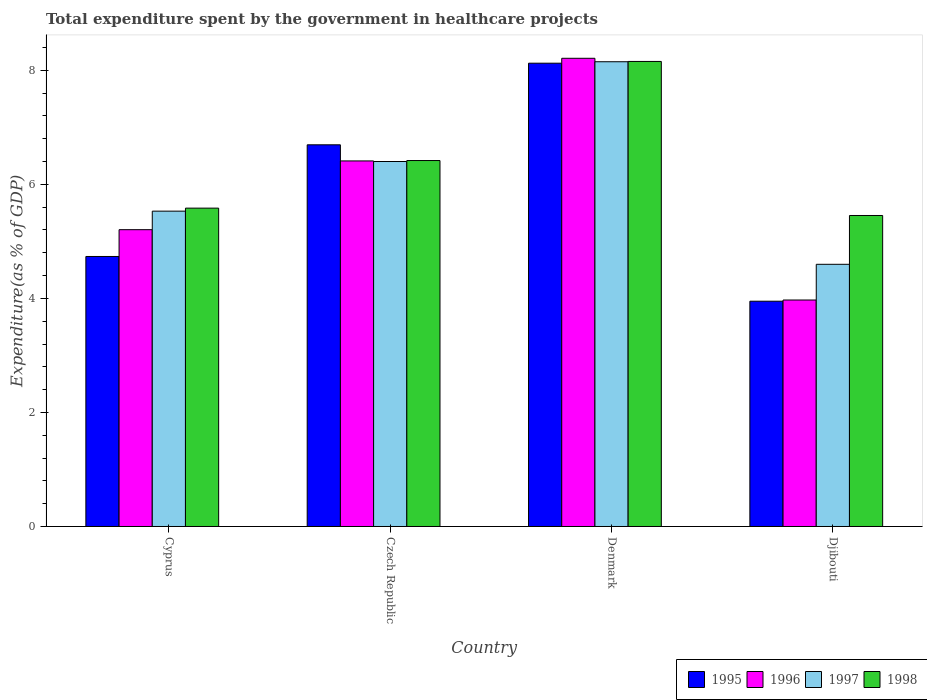How many groups of bars are there?
Make the answer very short. 4. Are the number of bars per tick equal to the number of legend labels?
Offer a very short reply. Yes. How many bars are there on the 1st tick from the right?
Make the answer very short. 4. What is the label of the 2nd group of bars from the left?
Offer a terse response. Czech Republic. In how many cases, is the number of bars for a given country not equal to the number of legend labels?
Keep it short and to the point. 0. What is the total expenditure spent by the government in healthcare projects in 1995 in Czech Republic?
Your answer should be compact. 6.69. Across all countries, what is the maximum total expenditure spent by the government in healthcare projects in 1998?
Your response must be concise. 8.16. Across all countries, what is the minimum total expenditure spent by the government in healthcare projects in 1995?
Provide a short and direct response. 3.95. In which country was the total expenditure spent by the government in healthcare projects in 1997 maximum?
Your answer should be compact. Denmark. In which country was the total expenditure spent by the government in healthcare projects in 1997 minimum?
Offer a very short reply. Djibouti. What is the total total expenditure spent by the government in healthcare projects in 1998 in the graph?
Your response must be concise. 25.61. What is the difference between the total expenditure spent by the government in healthcare projects in 1997 in Czech Republic and that in Djibouti?
Ensure brevity in your answer.  1.8. What is the difference between the total expenditure spent by the government in healthcare projects in 1995 in Denmark and the total expenditure spent by the government in healthcare projects in 1998 in Czech Republic?
Offer a very short reply. 1.71. What is the average total expenditure spent by the government in healthcare projects in 1996 per country?
Provide a short and direct response. 5.95. What is the difference between the total expenditure spent by the government in healthcare projects of/in 1997 and total expenditure spent by the government in healthcare projects of/in 1996 in Cyprus?
Your answer should be very brief. 0.32. What is the ratio of the total expenditure spent by the government in healthcare projects in 1997 in Denmark to that in Djibouti?
Offer a terse response. 1.77. Is the difference between the total expenditure spent by the government in healthcare projects in 1997 in Cyprus and Czech Republic greater than the difference between the total expenditure spent by the government in healthcare projects in 1996 in Cyprus and Czech Republic?
Ensure brevity in your answer.  Yes. What is the difference between the highest and the second highest total expenditure spent by the government in healthcare projects in 1996?
Offer a very short reply. 3.01. What is the difference between the highest and the lowest total expenditure spent by the government in healthcare projects in 1996?
Ensure brevity in your answer.  4.24. In how many countries, is the total expenditure spent by the government in healthcare projects in 1996 greater than the average total expenditure spent by the government in healthcare projects in 1996 taken over all countries?
Ensure brevity in your answer.  2. Is the sum of the total expenditure spent by the government in healthcare projects in 1997 in Denmark and Djibouti greater than the maximum total expenditure spent by the government in healthcare projects in 1996 across all countries?
Make the answer very short. Yes. Is it the case that in every country, the sum of the total expenditure spent by the government in healthcare projects in 1997 and total expenditure spent by the government in healthcare projects in 1996 is greater than the sum of total expenditure spent by the government in healthcare projects in 1995 and total expenditure spent by the government in healthcare projects in 1998?
Make the answer very short. No. What does the 4th bar from the left in Denmark represents?
Give a very brief answer. 1998. Are all the bars in the graph horizontal?
Your answer should be very brief. No. What is the difference between two consecutive major ticks on the Y-axis?
Provide a short and direct response. 2. Does the graph contain any zero values?
Your answer should be compact. No. Where does the legend appear in the graph?
Make the answer very short. Bottom right. How are the legend labels stacked?
Your answer should be compact. Horizontal. What is the title of the graph?
Offer a terse response. Total expenditure spent by the government in healthcare projects. Does "1984" appear as one of the legend labels in the graph?
Make the answer very short. No. What is the label or title of the Y-axis?
Ensure brevity in your answer.  Expenditure(as % of GDP). What is the Expenditure(as % of GDP) in 1995 in Cyprus?
Your response must be concise. 4.74. What is the Expenditure(as % of GDP) of 1996 in Cyprus?
Provide a succinct answer. 5.21. What is the Expenditure(as % of GDP) in 1997 in Cyprus?
Your answer should be very brief. 5.53. What is the Expenditure(as % of GDP) in 1998 in Cyprus?
Give a very brief answer. 5.58. What is the Expenditure(as % of GDP) in 1995 in Czech Republic?
Provide a short and direct response. 6.69. What is the Expenditure(as % of GDP) of 1996 in Czech Republic?
Offer a terse response. 6.41. What is the Expenditure(as % of GDP) of 1997 in Czech Republic?
Your answer should be very brief. 6.4. What is the Expenditure(as % of GDP) in 1998 in Czech Republic?
Ensure brevity in your answer.  6.42. What is the Expenditure(as % of GDP) of 1995 in Denmark?
Ensure brevity in your answer.  8.13. What is the Expenditure(as % of GDP) in 1996 in Denmark?
Your response must be concise. 8.21. What is the Expenditure(as % of GDP) of 1997 in Denmark?
Give a very brief answer. 8.15. What is the Expenditure(as % of GDP) in 1998 in Denmark?
Offer a terse response. 8.16. What is the Expenditure(as % of GDP) in 1995 in Djibouti?
Your answer should be compact. 3.95. What is the Expenditure(as % of GDP) of 1996 in Djibouti?
Your answer should be compact. 3.97. What is the Expenditure(as % of GDP) in 1997 in Djibouti?
Your response must be concise. 4.6. What is the Expenditure(as % of GDP) in 1998 in Djibouti?
Keep it short and to the point. 5.45. Across all countries, what is the maximum Expenditure(as % of GDP) of 1995?
Your answer should be very brief. 8.13. Across all countries, what is the maximum Expenditure(as % of GDP) of 1996?
Offer a very short reply. 8.21. Across all countries, what is the maximum Expenditure(as % of GDP) in 1997?
Your answer should be compact. 8.15. Across all countries, what is the maximum Expenditure(as % of GDP) in 1998?
Your response must be concise. 8.16. Across all countries, what is the minimum Expenditure(as % of GDP) of 1995?
Ensure brevity in your answer.  3.95. Across all countries, what is the minimum Expenditure(as % of GDP) of 1996?
Offer a very short reply. 3.97. Across all countries, what is the minimum Expenditure(as % of GDP) in 1997?
Offer a terse response. 4.6. Across all countries, what is the minimum Expenditure(as % of GDP) of 1998?
Give a very brief answer. 5.45. What is the total Expenditure(as % of GDP) of 1995 in the graph?
Keep it short and to the point. 23.51. What is the total Expenditure(as % of GDP) in 1996 in the graph?
Provide a succinct answer. 23.8. What is the total Expenditure(as % of GDP) in 1997 in the graph?
Make the answer very short. 24.68. What is the total Expenditure(as % of GDP) in 1998 in the graph?
Keep it short and to the point. 25.61. What is the difference between the Expenditure(as % of GDP) in 1995 in Cyprus and that in Czech Republic?
Give a very brief answer. -1.96. What is the difference between the Expenditure(as % of GDP) of 1996 in Cyprus and that in Czech Republic?
Your answer should be compact. -1.21. What is the difference between the Expenditure(as % of GDP) of 1997 in Cyprus and that in Czech Republic?
Your response must be concise. -0.87. What is the difference between the Expenditure(as % of GDP) in 1998 in Cyprus and that in Czech Republic?
Offer a terse response. -0.83. What is the difference between the Expenditure(as % of GDP) of 1995 in Cyprus and that in Denmark?
Provide a short and direct response. -3.39. What is the difference between the Expenditure(as % of GDP) of 1996 in Cyprus and that in Denmark?
Offer a very short reply. -3.01. What is the difference between the Expenditure(as % of GDP) of 1997 in Cyprus and that in Denmark?
Your answer should be compact. -2.62. What is the difference between the Expenditure(as % of GDP) of 1998 in Cyprus and that in Denmark?
Your response must be concise. -2.57. What is the difference between the Expenditure(as % of GDP) in 1995 in Cyprus and that in Djibouti?
Make the answer very short. 0.78. What is the difference between the Expenditure(as % of GDP) of 1996 in Cyprus and that in Djibouti?
Ensure brevity in your answer.  1.23. What is the difference between the Expenditure(as % of GDP) in 1997 in Cyprus and that in Djibouti?
Your response must be concise. 0.93. What is the difference between the Expenditure(as % of GDP) of 1998 in Cyprus and that in Djibouti?
Ensure brevity in your answer.  0.13. What is the difference between the Expenditure(as % of GDP) in 1995 in Czech Republic and that in Denmark?
Ensure brevity in your answer.  -1.43. What is the difference between the Expenditure(as % of GDP) of 1996 in Czech Republic and that in Denmark?
Your answer should be very brief. -1.8. What is the difference between the Expenditure(as % of GDP) in 1997 in Czech Republic and that in Denmark?
Provide a short and direct response. -1.75. What is the difference between the Expenditure(as % of GDP) of 1998 in Czech Republic and that in Denmark?
Provide a succinct answer. -1.74. What is the difference between the Expenditure(as % of GDP) of 1995 in Czech Republic and that in Djibouti?
Provide a succinct answer. 2.74. What is the difference between the Expenditure(as % of GDP) of 1996 in Czech Republic and that in Djibouti?
Offer a very short reply. 2.44. What is the difference between the Expenditure(as % of GDP) of 1997 in Czech Republic and that in Djibouti?
Keep it short and to the point. 1.8. What is the difference between the Expenditure(as % of GDP) of 1998 in Czech Republic and that in Djibouti?
Your answer should be very brief. 0.96. What is the difference between the Expenditure(as % of GDP) in 1995 in Denmark and that in Djibouti?
Your response must be concise. 4.17. What is the difference between the Expenditure(as % of GDP) in 1996 in Denmark and that in Djibouti?
Provide a short and direct response. 4.24. What is the difference between the Expenditure(as % of GDP) of 1997 in Denmark and that in Djibouti?
Your answer should be very brief. 3.55. What is the difference between the Expenditure(as % of GDP) of 1998 in Denmark and that in Djibouti?
Your answer should be very brief. 2.7. What is the difference between the Expenditure(as % of GDP) in 1995 in Cyprus and the Expenditure(as % of GDP) in 1996 in Czech Republic?
Keep it short and to the point. -1.68. What is the difference between the Expenditure(as % of GDP) of 1995 in Cyprus and the Expenditure(as % of GDP) of 1997 in Czech Republic?
Your answer should be very brief. -1.67. What is the difference between the Expenditure(as % of GDP) in 1995 in Cyprus and the Expenditure(as % of GDP) in 1998 in Czech Republic?
Offer a very short reply. -1.68. What is the difference between the Expenditure(as % of GDP) in 1996 in Cyprus and the Expenditure(as % of GDP) in 1997 in Czech Republic?
Your answer should be compact. -1.2. What is the difference between the Expenditure(as % of GDP) in 1996 in Cyprus and the Expenditure(as % of GDP) in 1998 in Czech Republic?
Offer a very short reply. -1.21. What is the difference between the Expenditure(as % of GDP) of 1997 in Cyprus and the Expenditure(as % of GDP) of 1998 in Czech Republic?
Your response must be concise. -0.89. What is the difference between the Expenditure(as % of GDP) in 1995 in Cyprus and the Expenditure(as % of GDP) in 1996 in Denmark?
Your answer should be very brief. -3.48. What is the difference between the Expenditure(as % of GDP) of 1995 in Cyprus and the Expenditure(as % of GDP) of 1997 in Denmark?
Provide a succinct answer. -3.42. What is the difference between the Expenditure(as % of GDP) in 1995 in Cyprus and the Expenditure(as % of GDP) in 1998 in Denmark?
Your response must be concise. -3.42. What is the difference between the Expenditure(as % of GDP) of 1996 in Cyprus and the Expenditure(as % of GDP) of 1997 in Denmark?
Provide a short and direct response. -2.95. What is the difference between the Expenditure(as % of GDP) of 1996 in Cyprus and the Expenditure(as % of GDP) of 1998 in Denmark?
Provide a short and direct response. -2.95. What is the difference between the Expenditure(as % of GDP) in 1997 in Cyprus and the Expenditure(as % of GDP) in 1998 in Denmark?
Your answer should be very brief. -2.63. What is the difference between the Expenditure(as % of GDP) in 1995 in Cyprus and the Expenditure(as % of GDP) in 1996 in Djibouti?
Your answer should be compact. 0.76. What is the difference between the Expenditure(as % of GDP) of 1995 in Cyprus and the Expenditure(as % of GDP) of 1997 in Djibouti?
Ensure brevity in your answer.  0.14. What is the difference between the Expenditure(as % of GDP) in 1995 in Cyprus and the Expenditure(as % of GDP) in 1998 in Djibouti?
Give a very brief answer. -0.72. What is the difference between the Expenditure(as % of GDP) in 1996 in Cyprus and the Expenditure(as % of GDP) in 1997 in Djibouti?
Give a very brief answer. 0.61. What is the difference between the Expenditure(as % of GDP) of 1996 in Cyprus and the Expenditure(as % of GDP) of 1998 in Djibouti?
Provide a short and direct response. -0.25. What is the difference between the Expenditure(as % of GDP) in 1997 in Cyprus and the Expenditure(as % of GDP) in 1998 in Djibouti?
Ensure brevity in your answer.  0.08. What is the difference between the Expenditure(as % of GDP) of 1995 in Czech Republic and the Expenditure(as % of GDP) of 1996 in Denmark?
Your answer should be very brief. -1.52. What is the difference between the Expenditure(as % of GDP) of 1995 in Czech Republic and the Expenditure(as % of GDP) of 1997 in Denmark?
Your answer should be very brief. -1.46. What is the difference between the Expenditure(as % of GDP) of 1995 in Czech Republic and the Expenditure(as % of GDP) of 1998 in Denmark?
Provide a succinct answer. -1.46. What is the difference between the Expenditure(as % of GDP) of 1996 in Czech Republic and the Expenditure(as % of GDP) of 1997 in Denmark?
Ensure brevity in your answer.  -1.74. What is the difference between the Expenditure(as % of GDP) of 1996 in Czech Republic and the Expenditure(as % of GDP) of 1998 in Denmark?
Keep it short and to the point. -1.74. What is the difference between the Expenditure(as % of GDP) of 1997 in Czech Republic and the Expenditure(as % of GDP) of 1998 in Denmark?
Your response must be concise. -1.76. What is the difference between the Expenditure(as % of GDP) of 1995 in Czech Republic and the Expenditure(as % of GDP) of 1996 in Djibouti?
Your answer should be very brief. 2.72. What is the difference between the Expenditure(as % of GDP) of 1995 in Czech Republic and the Expenditure(as % of GDP) of 1997 in Djibouti?
Keep it short and to the point. 2.1. What is the difference between the Expenditure(as % of GDP) in 1995 in Czech Republic and the Expenditure(as % of GDP) in 1998 in Djibouti?
Your response must be concise. 1.24. What is the difference between the Expenditure(as % of GDP) of 1996 in Czech Republic and the Expenditure(as % of GDP) of 1997 in Djibouti?
Your answer should be compact. 1.81. What is the difference between the Expenditure(as % of GDP) in 1996 in Czech Republic and the Expenditure(as % of GDP) in 1998 in Djibouti?
Ensure brevity in your answer.  0.96. What is the difference between the Expenditure(as % of GDP) in 1997 in Czech Republic and the Expenditure(as % of GDP) in 1998 in Djibouti?
Provide a succinct answer. 0.95. What is the difference between the Expenditure(as % of GDP) of 1995 in Denmark and the Expenditure(as % of GDP) of 1996 in Djibouti?
Your response must be concise. 4.15. What is the difference between the Expenditure(as % of GDP) of 1995 in Denmark and the Expenditure(as % of GDP) of 1997 in Djibouti?
Ensure brevity in your answer.  3.53. What is the difference between the Expenditure(as % of GDP) of 1995 in Denmark and the Expenditure(as % of GDP) of 1998 in Djibouti?
Ensure brevity in your answer.  2.67. What is the difference between the Expenditure(as % of GDP) of 1996 in Denmark and the Expenditure(as % of GDP) of 1997 in Djibouti?
Make the answer very short. 3.61. What is the difference between the Expenditure(as % of GDP) of 1996 in Denmark and the Expenditure(as % of GDP) of 1998 in Djibouti?
Provide a succinct answer. 2.76. What is the difference between the Expenditure(as % of GDP) in 1997 in Denmark and the Expenditure(as % of GDP) in 1998 in Djibouti?
Provide a succinct answer. 2.7. What is the average Expenditure(as % of GDP) in 1995 per country?
Your answer should be very brief. 5.88. What is the average Expenditure(as % of GDP) in 1996 per country?
Ensure brevity in your answer.  5.95. What is the average Expenditure(as % of GDP) in 1997 per country?
Give a very brief answer. 6.17. What is the average Expenditure(as % of GDP) of 1998 per country?
Keep it short and to the point. 6.4. What is the difference between the Expenditure(as % of GDP) of 1995 and Expenditure(as % of GDP) of 1996 in Cyprus?
Provide a succinct answer. -0.47. What is the difference between the Expenditure(as % of GDP) in 1995 and Expenditure(as % of GDP) in 1997 in Cyprus?
Provide a short and direct response. -0.79. What is the difference between the Expenditure(as % of GDP) in 1995 and Expenditure(as % of GDP) in 1998 in Cyprus?
Provide a short and direct response. -0.85. What is the difference between the Expenditure(as % of GDP) in 1996 and Expenditure(as % of GDP) in 1997 in Cyprus?
Your answer should be very brief. -0.33. What is the difference between the Expenditure(as % of GDP) of 1996 and Expenditure(as % of GDP) of 1998 in Cyprus?
Provide a succinct answer. -0.38. What is the difference between the Expenditure(as % of GDP) of 1997 and Expenditure(as % of GDP) of 1998 in Cyprus?
Offer a very short reply. -0.05. What is the difference between the Expenditure(as % of GDP) in 1995 and Expenditure(as % of GDP) in 1996 in Czech Republic?
Offer a very short reply. 0.28. What is the difference between the Expenditure(as % of GDP) of 1995 and Expenditure(as % of GDP) of 1997 in Czech Republic?
Your answer should be very brief. 0.29. What is the difference between the Expenditure(as % of GDP) of 1995 and Expenditure(as % of GDP) of 1998 in Czech Republic?
Make the answer very short. 0.28. What is the difference between the Expenditure(as % of GDP) in 1996 and Expenditure(as % of GDP) in 1997 in Czech Republic?
Your response must be concise. 0.01. What is the difference between the Expenditure(as % of GDP) in 1996 and Expenditure(as % of GDP) in 1998 in Czech Republic?
Provide a short and direct response. -0.01. What is the difference between the Expenditure(as % of GDP) in 1997 and Expenditure(as % of GDP) in 1998 in Czech Republic?
Offer a very short reply. -0.02. What is the difference between the Expenditure(as % of GDP) of 1995 and Expenditure(as % of GDP) of 1996 in Denmark?
Offer a terse response. -0.09. What is the difference between the Expenditure(as % of GDP) of 1995 and Expenditure(as % of GDP) of 1997 in Denmark?
Keep it short and to the point. -0.03. What is the difference between the Expenditure(as % of GDP) of 1995 and Expenditure(as % of GDP) of 1998 in Denmark?
Keep it short and to the point. -0.03. What is the difference between the Expenditure(as % of GDP) in 1996 and Expenditure(as % of GDP) in 1997 in Denmark?
Offer a terse response. 0.06. What is the difference between the Expenditure(as % of GDP) in 1996 and Expenditure(as % of GDP) in 1998 in Denmark?
Your response must be concise. 0.06. What is the difference between the Expenditure(as % of GDP) in 1997 and Expenditure(as % of GDP) in 1998 in Denmark?
Ensure brevity in your answer.  -0.01. What is the difference between the Expenditure(as % of GDP) in 1995 and Expenditure(as % of GDP) in 1996 in Djibouti?
Your response must be concise. -0.02. What is the difference between the Expenditure(as % of GDP) of 1995 and Expenditure(as % of GDP) of 1997 in Djibouti?
Give a very brief answer. -0.65. What is the difference between the Expenditure(as % of GDP) in 1995 and Expenditure(as % of GDP) in 1998 in Djibouti?
Make the answer very short. -1.5. What is the difference between the Expenditure(as % of GDP) in 1996 and Expenditure(as % of GDP) in 1997 in Djibouti?
Your answer should be very brief. -0.63. What is the difference between the Expenditure(as % of GDP) in 1996 and Expenditure(as % of GDP) in 1998 in Djibouti?
Provide a succinct answer. -1.48. What is the difference between the Expenditure(as % of GDP) of 1997 and Expenditure(as % of GDP) of 1998 in Djibouti?
Your response must be concise. -0.86. What is the ratio of the Expenditure(as % of GDP) of 1995 in Cyprus to that in Czech Republic?
Ensure brevity in your answer.  0.71. What is the ratio of the Expenditure(as % of GDP) of 1996 in Cyprus to that in Czech Republic?
Offer a terse response. 0.81. What is the ratio of the Expenditure(as % of GDP) of 1997 in Cyprus to that in Czech Republic?
Ensure brevity in your answer.  0.86. What is the ratio of the Expenditure(as % of GDP) in 1998 in Cyprus to that in Czech Republic?
Make the answer very short. 0.87. What is the ratio of the Expenditure(as % of GDP) of 1995 in Cyprus to that in Denmark?
Offer a very short reply. 0.58. What is the ratio of the Expenditure(as % of GDP) of 1996 in Cyprus to that in Denmark?
Your answer should be very brief. 0.63. What is the ratio of the Expenditure(as % of GDP) of 1997 in Cyprus to that in Denmark?
Your answer should be compact. 0.68. What is the ratio of the Expenditure(as % of GDP) in 1998 in Cyprus to that in Denmark?
Offer a very short reply. 0.68. What is the ratio of the Expenditure(as % of GDP) of 1995 in Cyprus to that in Djibouti?
Your answer should be very brief. 1.2. What is the ratio of the Expenditure(as % of GDP) in 1996 in Cyprus to that in Djibouti?
Give a very brief answer. 1.31. What is the ratio of the Expenditure(as % of GDP) of 1997 in Cyprus to that in Djibouti?
Ensure brevity in your answer.  1.2. What is the ratio of the Expenditure(as % of GDP) in 1998 in Cyprus to that in Djibouti?
Provide a succinct answer. 1.02. What is the ratio of the Expenditure(as % of GDP) of 1995 in Czech Republic to that in Denmark?
Make the answer very short. 0.82. What is the ratio of the Expenditure(as % of GDP) of 1996 in Czech Republic to that in Denmark?
Offer a very short reply. 0.78. What is the ratio of the Expenditure(as % of GDP) of 1997 in Czech Republic to that in Denmark?
Your response must be concise. 0.79. What is the ratio of the Expenditure(as % of GDP) of 1998 in Czech Republic to that in Denmark?
Your answer should be compact. 0.79. What is the ratio of the Expenditure(as % of GDP) in 1995 in Czech Republic to that in Djibouti?
Offer a very short reply. 1.69. What is the ratio of the Expenditure(as % of GDP) of 1996 in Czech Republic to that in Djibouti?
Your answer should be very brief. 1.61. What is the ratio of the Expenditure(as % of GDP) in 1997 in Czech Republic to that in Djibouti?
Offer a terse response. 1.39. What is the ratio of the Expenditure(as % of GDP) in 1998 in Czech Republic to that in Djibouti?
Ensure brevity in your answer.  1.18. What is the ratio of the Expenditure(as % of GDP) of 1995 in Denmark to that in Djibouti?
Provide a short and direct response. 2.06. What is the ratio of the Expenditure(as % of GDP) of 1996 in Denmark to that in Djibouti?
Your answer should be compact. 2.07. What is the ratio of the Expenditure(as % of GDP) of 1997 in Denmark to that in Djibouti?
Offer a terse response. 1.77. What is the ratio of the Expenditure(as % of GDP) of 1998 in Denmark to that in Djibouti?
Make the answer very short. 1.5. What is the difference between the highest and the second highest Expenditure(as % of GDP) in 1995?
Your response must be concise. 1.43. What is the difference between the highest and the second highest Expenditure(as % of GDP) of 1996?
Give a very brief answer. 1.8. What is the difference between the highest and the second highest Expenditure(as % of GDP) in 1997?
Make the answer very short. 1.75. What is the difference between the highest and the second highest Expenditure(as % of GDP) of 1998?
Your response must be concise. 1.74. What is the difference between the highest and the lowest Expenditure(as % of GDP) of 1995?
Offer a very short reply. 4.17. What is the difference between the highest and the lowest Expenditure(as % of GDP) of 1996?
Your answer should be very brief. 4.24. What is the difference between the highest and the lowest Expenditure(as % of GDP) in 1997?
Your response must be concise. 3.55. What is the difference between the highest and the lowest Expenditure(as % of GDP) in 1998?
Provide a succinct answer. 2.7. 